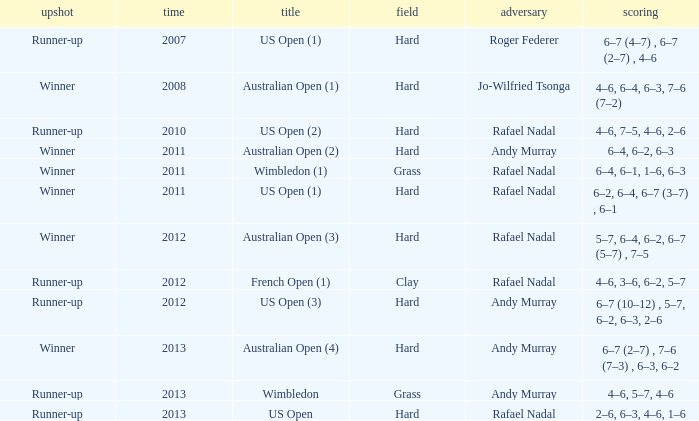What is the outcome of the match with Roger Federer as the opponent? Runner-up. 